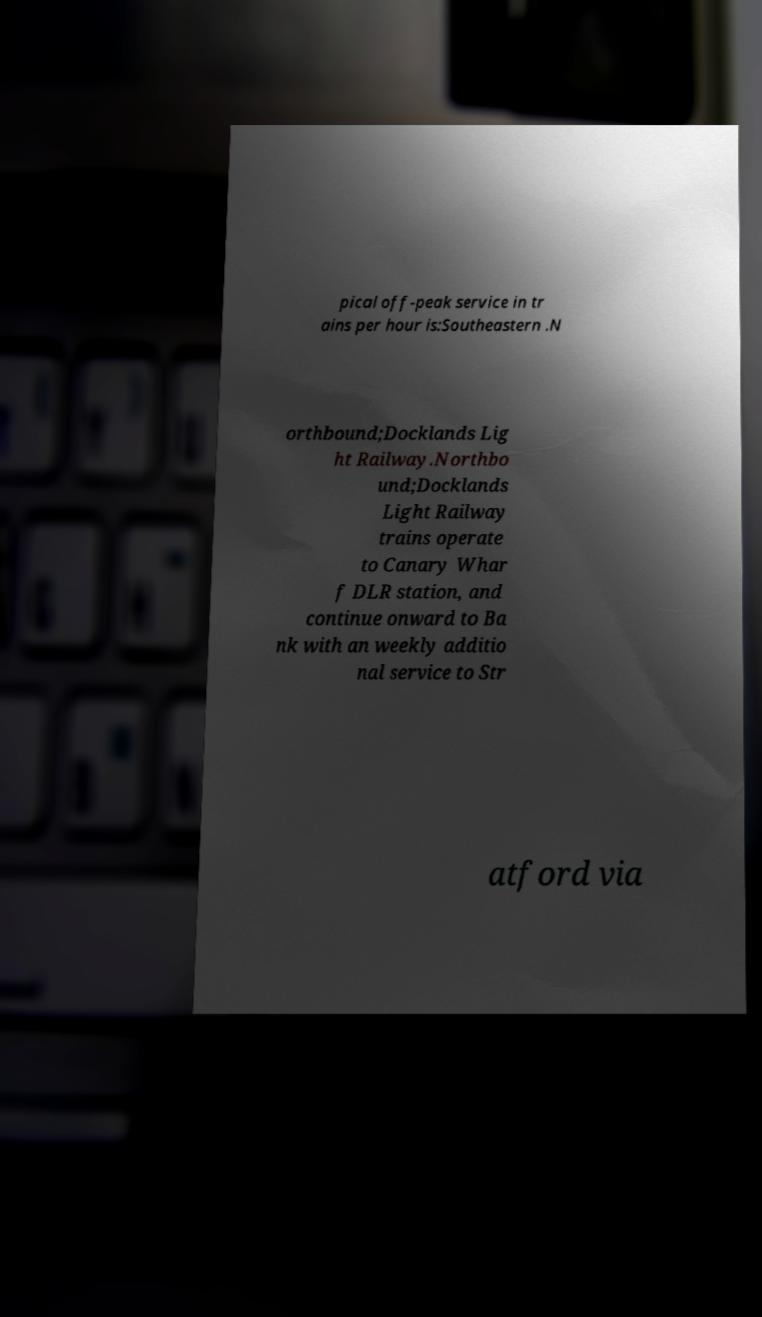Can you accurately transcribe the text from the provided image for me? pical off-peak service in tr ains per hour is:Southeastern .N orthbound;Docklands Lig ht Railway.Northbo und;Docklands Light Railway trains operate to Canary Whar f DLR station, and continue onward to Ba nk with an weekly additio nal service to Str atford via 